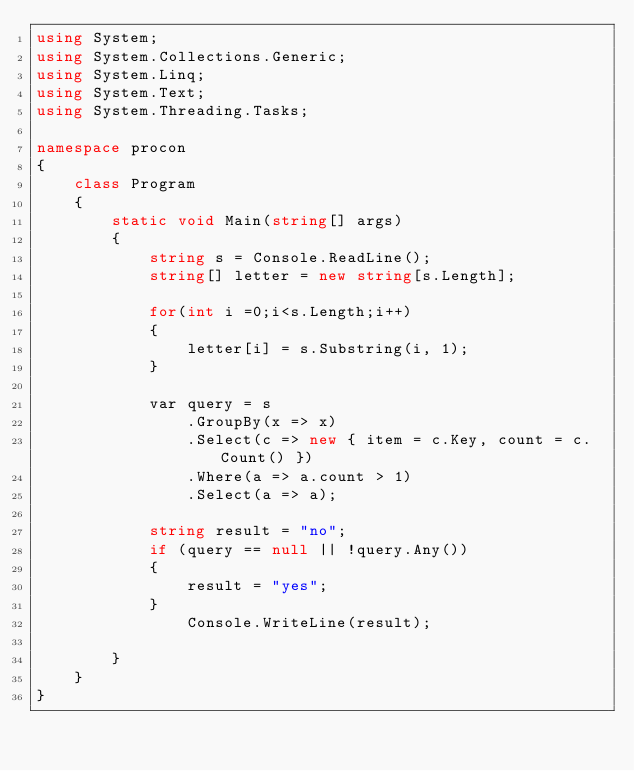<code> <loc_0><loc_0><loc_500><loc_500><_C#_>using System;
using System.Collections.Generic;
using System.Linq;
using System.Text;
using System.Threading.Tasks;

namespace procon
{
    class Program
    {
        static void Main(string[] args)
        {
            string s = Console.ReadLine();
            string[] letter = new string[s.Length];

            for(int i =0;i<s.Length;i++)
            {
                letter[i] = s.Substring(i, 1);
            }

            var query = s
                .GroupBy(x => x)
                .Select(c => new { item = c.Key, count = c.Count() })
                .Where(a => a.count > 1)
                .Select(a => a);

            string result = "no";
            if (query == null || !query.Any())
            {
                result = "yes";
            }
                Console.WriteLine(result);
            
        }
    }
}</code> 